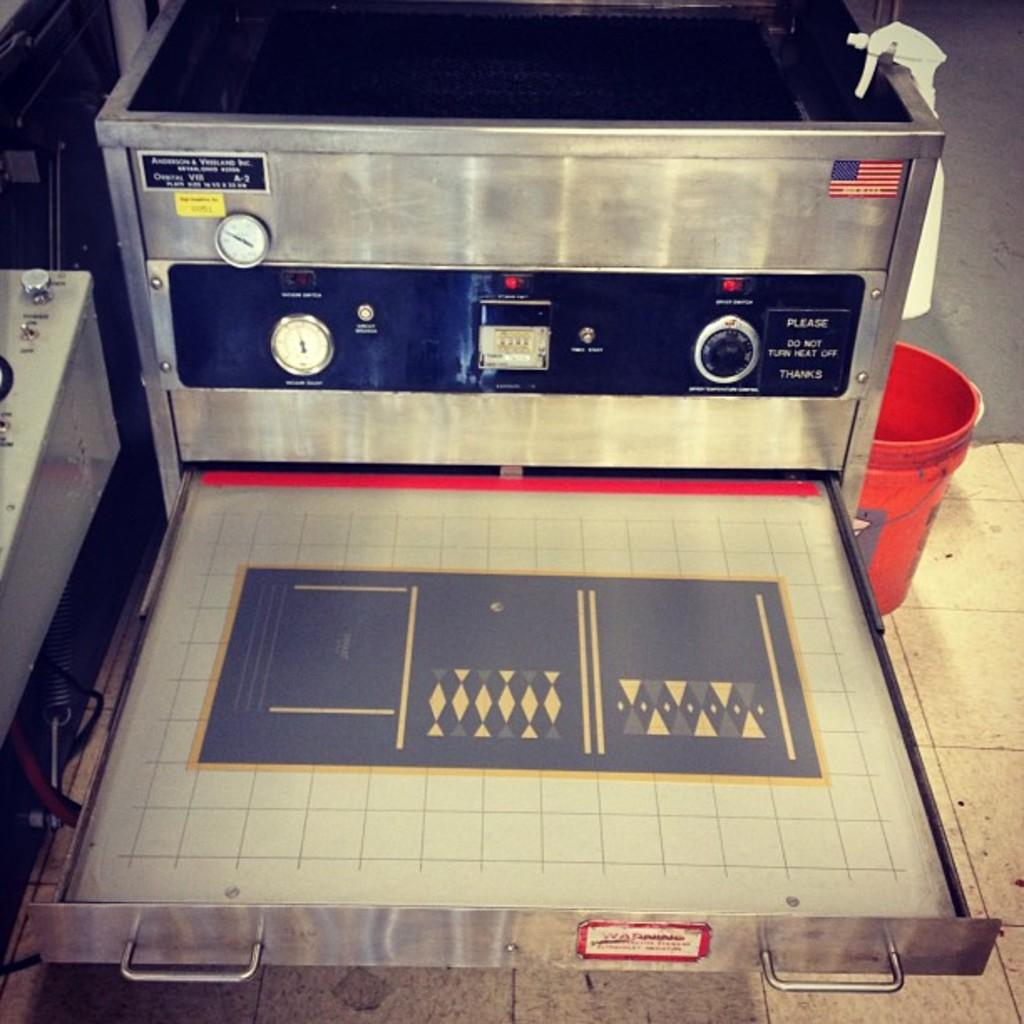<image>
Render a clear and concise summary of the photo. A vintage American made control panel with "Please do not turn heat off, Thanks" beside  a dial. 